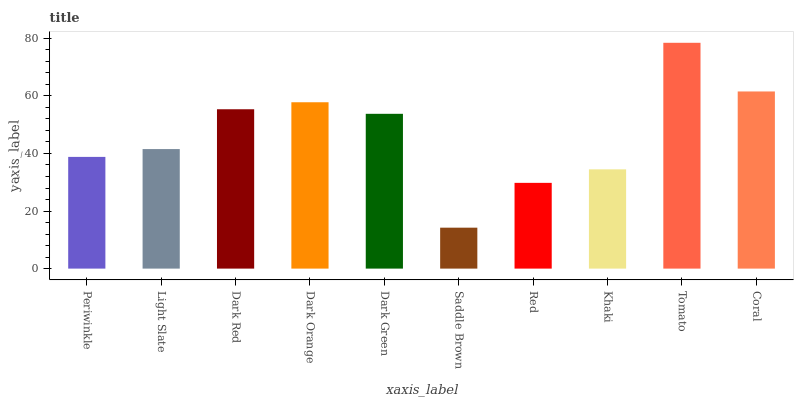Is Saddle Brown the minimum?
Answer yes or no. Yes. Is Tomato the maximum?
Answer yes or no. Yes. Is Light Slate the minimum?
Answer yes or no. No. Is Light Slate the maximum?
Answer yes or no. No. Is Light Slate greater than Periwinkle?
Answer yes or no. Yes. Is Periwinkle less than Light Slate?
Answer yes or no. Yes. Is Periwinkle greater than Light Slate?
Answer yes or no. No. Is Light Slate less than Periwinkle?
Answer yes or no. No. Is Dark Green the high median?
Answer yes or no. Yes. Is Light Slate the low median?
Answer yes or no. Yes. Is Coral the high median?
Answer yes or no. No. Is Coral the low median?
Answer yes or no. No. 